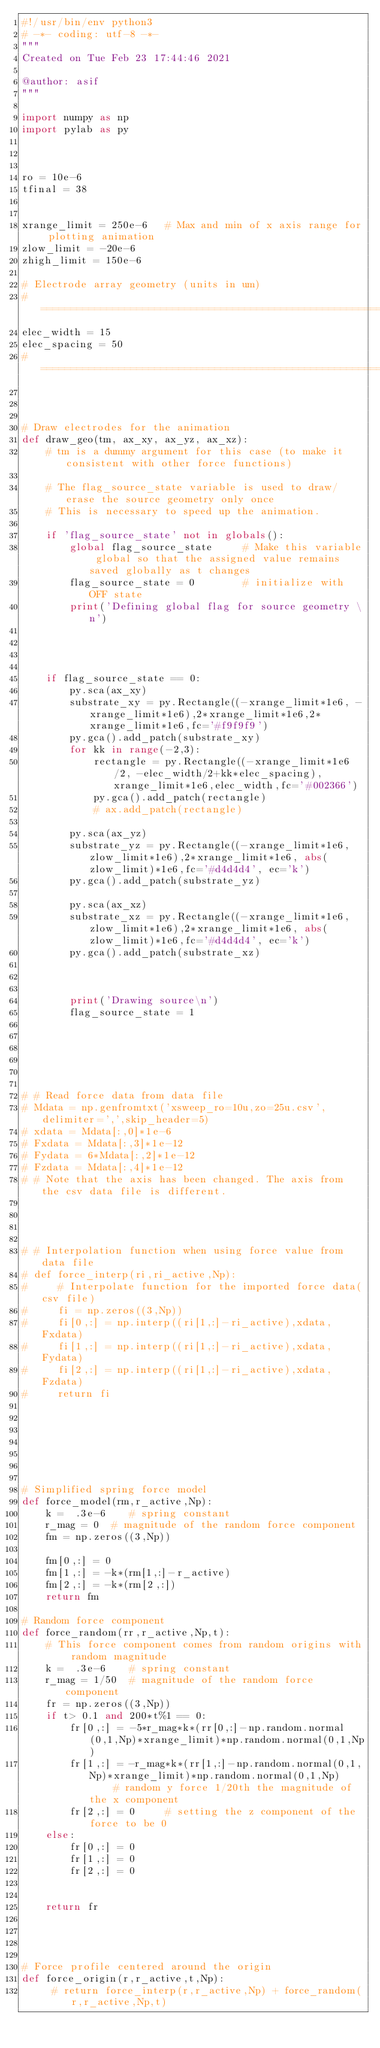<code> <loc_0><loc_0><loc_500><loc_500><_Python_>#!/usr/bin/env python3
# -*- coding: utf-8 -*-
"""
Created on Tue Feb 23 17:44:46 2021

@author: asif
"""

import numpy as np
import pylab as py



ro = 10e-6
tfinal = 38


xrange_limit = 250e-6   # Max and min of x axis range for plotting animation
zlow_limit = -20e-6
zhigh_limit = 150e-6

# Electrode array geometry (units in um)
# =============================================================================
elec_width = 15
elec_spacing = 50
# =============================================================================



# Draw electrodes for the animation
def draw_geo(tm, ax_xy, ax_yz, ax_xz):
    # tm is a dummy argument for this case (to make it consistent with other force functions)
    
    # The flag_source_state variable is used to draw/erase the source geometry only once
    # This is necessary to speed up the animation.
    
    if 'flag_source_state' not in globals():
        global flag_source_state     # Make this variable global so that the assigned value remains saved globally as t changes
        flag_source_state = 0        # initialize with OFF state
        print('Defining global flag for source geometry \n')
        
    
    
    
    if flag_source_state == 0:
        py.sca(ax_xy)
        substrate_xy = py.Rectangle((-xrange_limit*1e6, -xrange_limit*1e6),2*xrange_limit*1e6,2*xrange_limit*1e6,fc='#f9f9f9')
        py.gca().add_patch(substrate_xy)
        for kk in range(-2,3):
            rectangle = py.Rectangle((-xrange_limit*1e6/2, -elec_width/2+kk*elec_spacing),xrange_limit*1e6,elec_width,fc='#002366')
            py.gca().add_patch(rectangle)
            # ax.add_patch(rectangle)
        
        py.sca(ax_yz)
        substrate_yz = py.Rectangle((-xrange_limit*1e6, zlow_limit*1e6),2*xrange_limit*1e6, abs(zlow_limit)*1e6,fc='#d4d4d4', ec='k')
        py.gca().add_patch(substrate_yz)
         
        py.sca(ax_xz)
        substrate_xz = py.Rectangle((-xrange_limit*1e6, zlow_limit*1e6),2*xrange_limit*1e6, abs(zlow_limit)*1e6,fc='#d4d4d4', ec='k')
        py.gca().add_patch(substrate_xz)

        
        
        print('Drawing source\n')
        flag_source_state = 1






# # Read force data from data file
# Mdata = np.genfromtxt('xsweep_ro=10u,zo=25u.csv',delimiter=',',skip_header=5)
# xdata = Mdata[:,0]*1e-6
# Fxdata = Mdata[:,3]*1e-12
# Fydata = 6*Mdata[:,2]*1e-12
# Fzdata = Mdata[:,4]*1e-12
# # Note that the axis has been changed. The axis from the csv data file is different.




# # Interpolation function when using force value from data file    
# def force_interp(ri,ri_active,Np):
#     # Interpolate function for the imported force data(csv file)
#     fi = np.zeros((3,Np))
#     fi[0,:] = np.interp((ri[1,:]-ri_active),xdata,Fxdata)  
#     fi[1,:] = np.interp((ri[1,:]-ri_active),xdata,Fydata)
#     fi[2,:] = np.interp((ri[1,:]-ri_active),xdata,Fzdata)
#     return fi







# Simplified spring force model
def force_model(rm,r_active,Np):
    k =  .3e-6    # spring constant
    r_mag = 0  # magnitude of the random force component
    fm = np.zeros((3,Np))
    
    fm[0,:] = 0
    fm[1,:] = -k*(rm[1,:]-r_active)
    fm[2,:] = -k*(rm[2,:])     
    return fm

# Random force component
def force_random(rr,r_active,Np,t):
    # This force component comes from random origins with random magnitude
    k =  .3e-6    # spring constant
    r_mag = 1/50  # magnitude of the random force component
    fr = np.zeros((3,Np))
    if t> 0.1 and 200*t%1 == 0:
        fr[0,:] = -5*r_mag*k*(rr[0,:]-np.random.normal(0,1,Np)*xrange_limit)*np.random.normal(0,1,Np)
        fr[1,:] = -r_mag*k*(rr[1,:]-np.random.normal(0,1,Np)*xrange_limit)*np.random.normal(0,1,Np)     # random y force 1/20th the magnitude of the x component
        fr[2,:] = 0     # setting the z component of the force to be 0
    else:
        fr[0,:] = 0
        fr[1,:] = 0
        fr[2,:] = 0
    
    
    return fr




# Force profile centered around the origin    
def force_origin(r,r_active,t,Np):
     # return force_interp(r,r_active,Np) + force_random(r,r_active,Np,t)</code> 